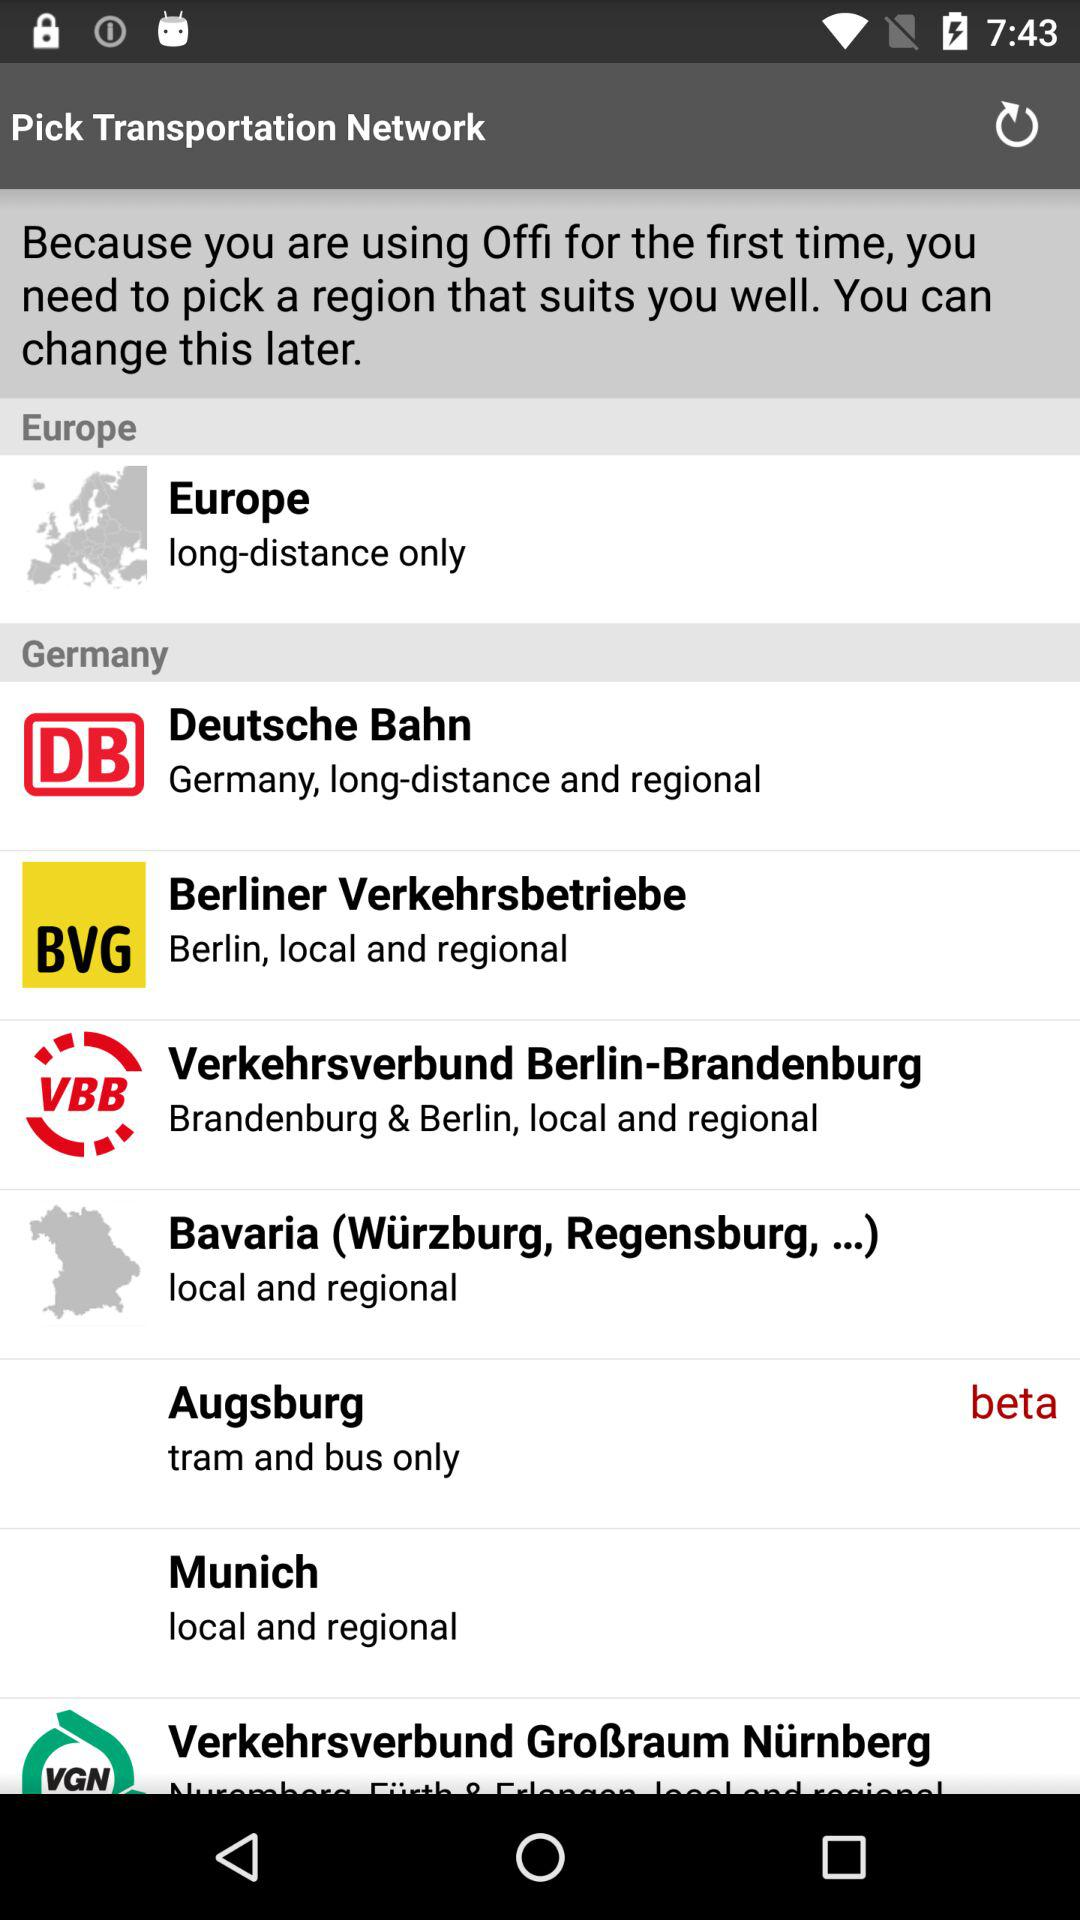What is the available list of region options? The available list of region options is "Europe", "Deutsche Bahn", "Berliner Verkehrsbetriebe", "Verkehrsverbund Berlin-Brandenburg", "Bavaria (Würzburg, Regensburg,...)", "Augsburg", "Munich" and "Verkehrsverbund Großraum Nürnberg". 